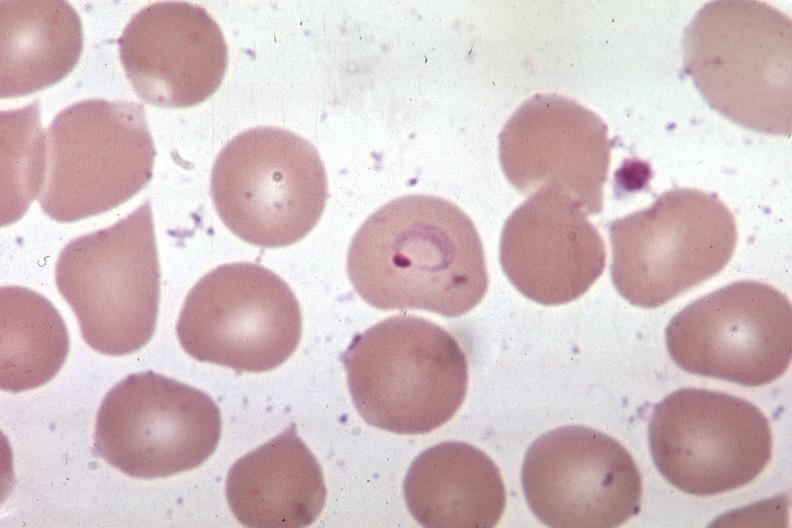s adrenal of premature 30 week gestation gram infant lesion present?
Answer the question using a single word or phrase. No 